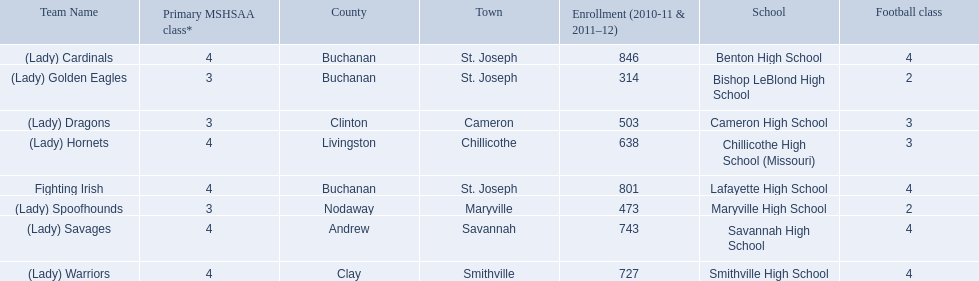What are all of the schools? Benton High School, Bishop LeBlond High School, Cameron High School, Chillicothe High School (Missouri), Lafayette High School, Maryville High School, Savannah High School, Smithville High School. How many football classes do they have? 4, 2, 3, 3, 4, 2, 4, 4. What about their enrollment? 846, 314, 503, 638, 801, 473, 743, 727. Which schools have 3 football classes? Cameron High School, Chillicothe High School (Missouri). And of those schools, which has 638 students? Chillicothe High School (Missouri). What are the names of the schools? Benton High School, Bishop LeBlond High School, Cameron High School, Chillicothe High School (Missouri), Lafayette High School, Maryville High School, Savannah High School, Smithville High School. Of those, which had a total enrollment of less than 500? Bishop LeBlond High School, Maryville High School. And of those, which had the lowest enrollment? Bishop LeBlond High School. 